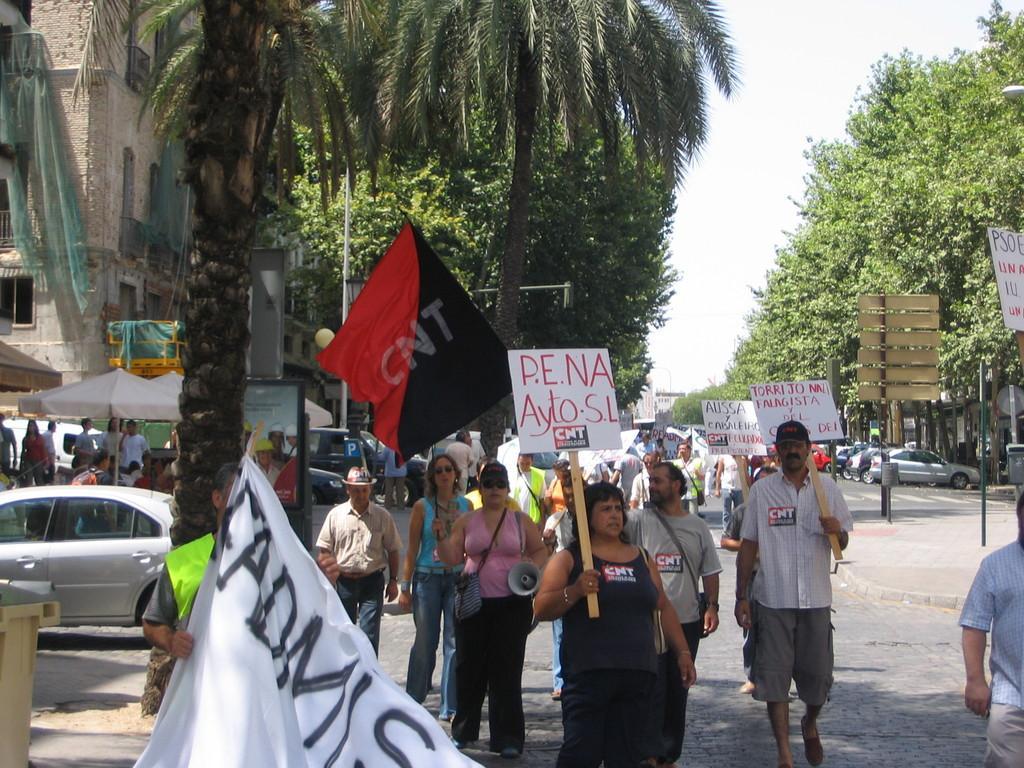Describe this image in one or two sentences. In this image, we can see people holding boards and banners and in the background, there are trees, buildings, vehicles, tents, poles, sign boards. At the bottom, there is road and at the top, there is sky. 